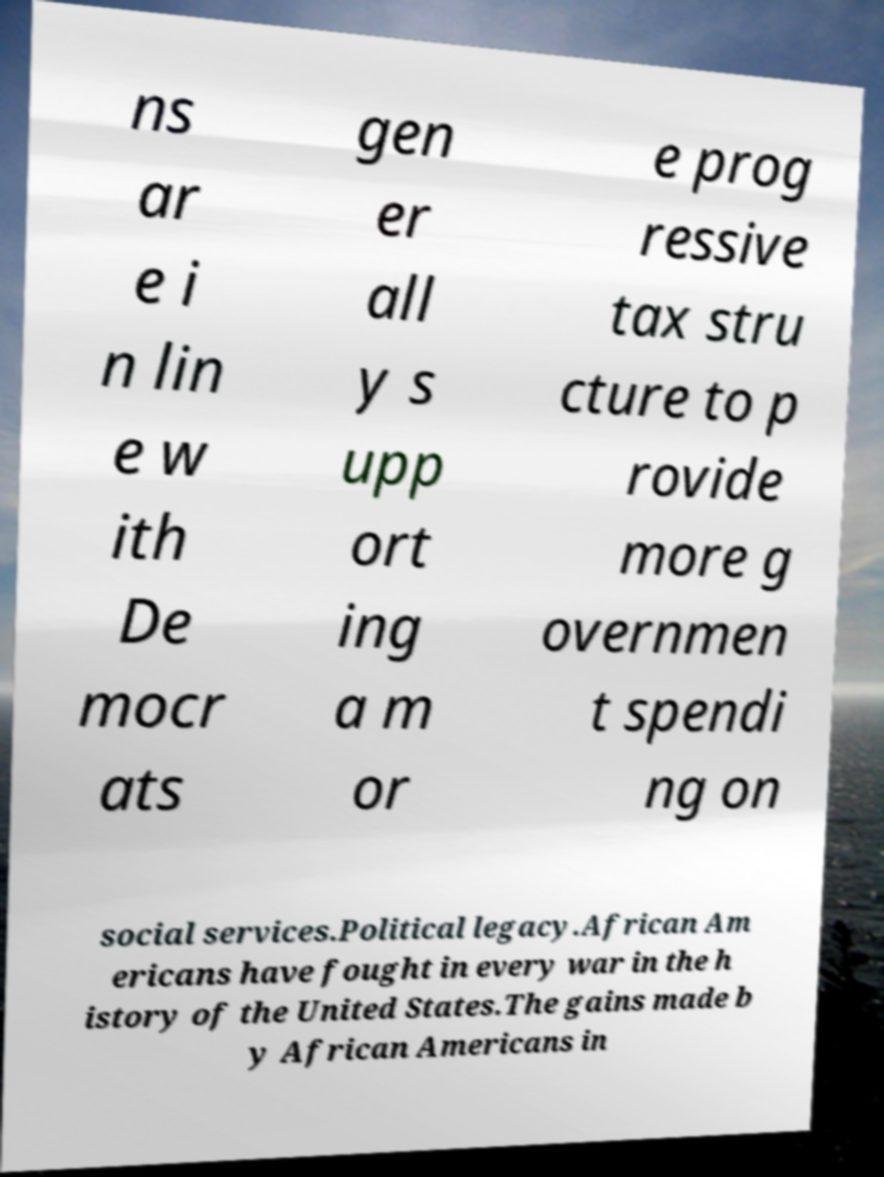Please read and relay the text visible in this image. What does it say? ns ar e i n lin e w ith De mocr ats gen er all y s upp ort ing a m or e prog ressive tax stru cture to p rovide more g overnmen t spendi ng on social services.Political legacy.African Am ericans have fought in every war in the h istory of the United States.The gains made b y African Americans in 